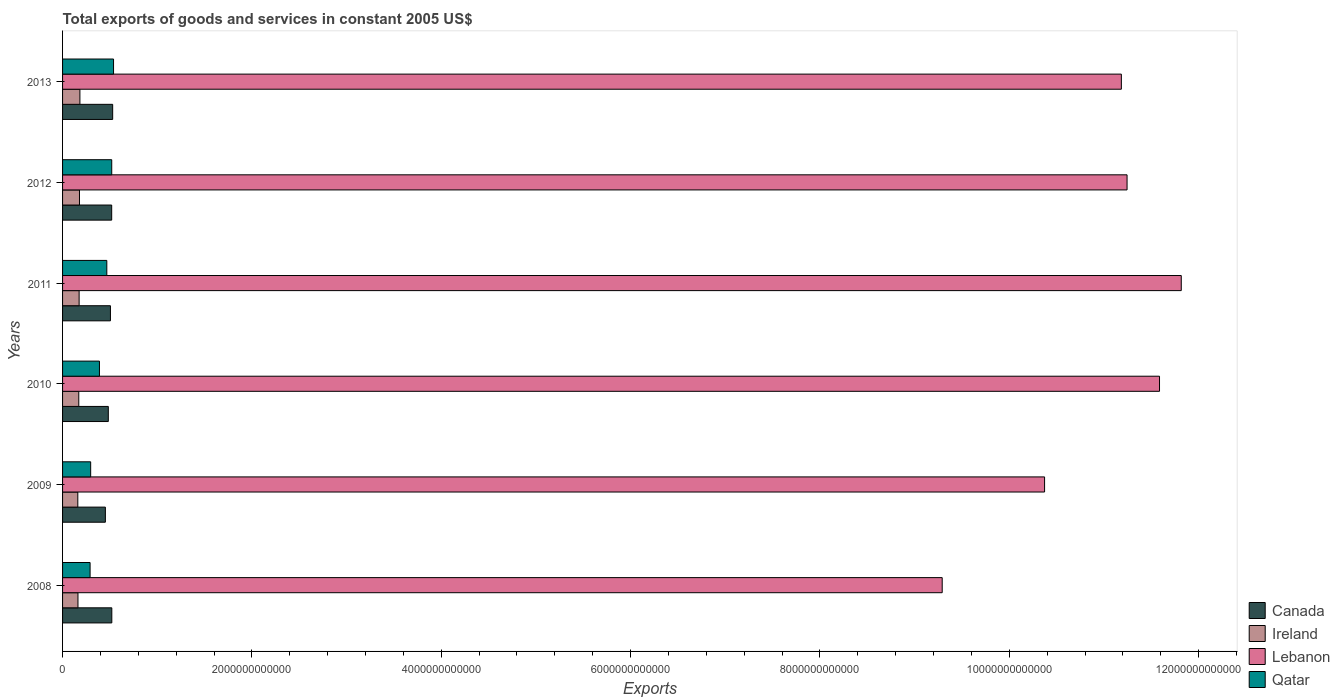How many different coloured bars are there?
Keep it short and to the point. 4. Are the number of bars per tick equal to the number of legend labels?
Offer a terse response. Yes. Are the number of bars on each tick of the Y-axis equal?
Give a very brief answer. Yes. What is the label of the 3rd group of bars from the top?
Offer a terse response. 2011. In how many cases, is the number of bars for a given year not equal to the number of legend labels?
Provide a short and direct response. 0. What is the total exports of goods and services in Canada in 2008?
Provide a short and direct response. 5.20e+11. Across all years, what is the maximum total exports of goods and services in Ireland?
Your response must be concise. 1.83e+11. Across all years, what is the minimum total exports of goods and services in Qatar?
Offer a very short reply. 2.91e+11. What is the total total exports of goods and services in Lebanon in the graph?
Provide a succinct answer. 6.55e+13. What is the difference between the total exports of goods and services in Canada in 2009 and that in 2010?
Offer a very short reply. -3.10e+1. What is the difference between the total exports of goods and services in Lebanon in 2010 and the total exports of goods and services in Qatar in 2009?
Make the answer very short. 1.13e+13. What is the average total exports of goods and services in Canada per year?
Offer a very short reply. 5.02e+11. In the year 2012, what is the difference between the total exports of goods and services in Ireland and total exports of goods and services in Lebanon?
Your answer should be compact. -1.11e+13. In how many years, is the total exports of goods and services in Ireland greater than 11200000000000 US$?
Provide a succinct answer. 0. What is the ratio of the total exports of goods and services in Lebanon in 2009 to that in 2010?
Your response must be concise. 0.9. Is the difference between the total exports of goods and services in Ireland in 2009 and 2013 greater than the difference between the total exports of goods and services in Lebanon in 2009 and 2013?
Offer a terse response. Yes. What is the difference between the highest and the second highest total exports of goods and services in Ireland?
Give a very brief answer. 4.43e+09. What is the difference between the highest and the lowest total exports of goods and services in Qatar?
Your answer should be compact. 2.48e+11. Is the sum of the total exports of goods and services in Lebanon in 2012 and 2013 greater than the maximum total exports of goods and services in Canada across all years?
Your response must be concise. Yes. What does the 2nd bar from the top in 2010 represents?
Provide a succinct answer. Lebanon. What does the 4th bar from the bottom in 2012 represents?
Provide a succinct answer. Qatar. How many bars are there?
Your answer should be compact. 24. Are all the bars in the graph horizontal?
Provide a succinct answer. Yes. What is the difference between two consecutive major ticks on the X-axis?
Give a very brief answer. 2.00e+12. Are the values on the major ticks of X-axis written in scientific E-notation?
Provide a succinct answer. No. Does the graph contain any zero values?
Provide a succinct answer. No. Does the graph contain grids?
Your answer should be very brief. No. What is the title of the graph?
Keep it short and to the point. Total exports of goods and services in constant 2005 US$. Does "Malaysia" appear as one of the legend labels in the graph?
Make the answer very short. No. What is the label or title of the X-axis?
Give a very brief answer. Exports. What is the Exports of Canada in 2008?
Your response must be concise. 5.20e+11. What is the Exports in Ireland in 2008?
Keep it short and to the point. 1.63e+11. What is the Exports in Lebanon in 2008?
Offer a terse response. 9.29e+12. What is the Exports in Qatar in 2008?
Provide a short and direct response. 2.91e+11. What is the Exports in Canada in 2009?
Your answer should be very brief. 4.52e+11. What is the Exports of Ireland in 2009?
Provide a succinct answer. 1.61e+11. What is the Exports in Lebanon in 2009?
Make the answer very short. 1.04e+13. What is the Exports in Qatar in 2009?
Your answer should be very brief. 2.97e+11. What is the Exports of Canada in 2010?
Your answer should be compact. 4.83e+11. What is the Exports of Ireland in 2010?
Provide a succinct answer. 1.71e+11. What is the Exports in Lebanon in 2010?
Offer a very short reply. 1.16e+13. What is the Exports of Qatar in 2010?
Offer a terse response. 3.90e+11. What is the Exports in Canada in 2011?
Your response must be concise. 5.06e+11. What is the Exports of Ireland in 2011?
Your answer should be very brief. 1.75e+11. What is the Exports in Lebanon in 2011?
Ensure brevity in your answer.  1.18e+13. What is the Exports of Qatar in 2011?
Give a very brief answer. 4.67e+11. What is the Exports of Canada in 2012?
Offer a very short reply. 5.19e+11. What is the Exports in Ireland in 2012?
Your answer should be compact. 1.79e+11. What is the Exports in Lebanon in 2012?
Your answer should be compact. 1.12e+13. What is the Exports of Qatar in 2012?
Offer a very short reply. 5.19e+11. What is the Exports of Canada in 2013?
Provide a short and direct response. 5.29e+11. What is the Exports of Ireland in 2013?
Your answer should be very brief. 1.83e+11. What is the Exports of Lebanon in 2013?
Offer a terse response. 1.12e+13. What is the Exports in Qatar in 2013?
Offer a terse response. 5.39e+11. Across all years, what is the maximum Exports in Canada?
Your answer should be compact. 5.29e+11. Across all years, what is the maximum Exports of Ireland?
Give a very brief answer. 1.83e+11. Across all years, what is the maximum Exports of Lebanon?
Provide a succinct answer. 1.18e+13. Across all years, what is the maximum Exports in Qatar?
Make the answer very short. 5.39e+11. Across all years, what is the minimum Exports in Canada?
Give a very brief answer. 4.52e+11. Across all years, what is the minimum Exports of Ireland?
Make the answer very short. 1.61e+11. Across all years, what is the minimum Exports in Lebanon?
Your answer should be very brief. 9.29e+12. Across all years, what is the minimum Exports in Qatar?
Keep it short and to the point. 2.91e+11. What is the total Exports in Canada in the graph?
Your response must be concise. 3.01e+12. What is the total Exports of Ireland in the graph?
Your answer should be compact. 1.03e+12. What is the total Exports of Lebanon in the graph?
Ensure brevity in your answer.  6.55e+13. What is the total Exports in Qatar in the graph?
Your answer should be very brief. 2.50e+12. What is the difference between the Exports of Canada in 2008 and that in 2009?
Give a very brief answer. 6.80e+1. What is the difference between the Exports of Ireland in 2008 and that in 2009?
Provide a succinct answer. 1.73e+09. What is the difference between the Exports of Lebanon in 2008 and that in 2009?
Your answer should be compact. -1.08e+12. What is the difference between the Exports of Qatar in 2008 and that in 2009?
Keep it short and to the point. -6.06e+09. What is the difference between the Exports of Canada in 2008 and that in 2010?
Give a very brief answer. 3.70e+1. What is the difference between the Exports of Ireland in 2008 and that in 2010?
Keep it short and to the point. -8.60e+09. What is the difference between the Exports in Lebanon in 2008 and that in 2010?
Provide a succinct answer. -2.30e+12. What is the difference between the Exports of Qatar in 2008 and that in 2010?
Provide a short and direct response. -9.89e+1. What is the difference between the Exports of Canada in 2008 and that in 2011?
Offer a terse response. 1.46e+1. What is the difference between the Exports of Ireland in 2008 and that in 2011?
Provide a short and direct response. -1.22e+1. What is the difference between the Exports of Lebanon in 2008 and that in 2011?
Ensure brevity in your answer.  -2.53e+12. What is the difference between the Exports of Qatar in 2008 and that in 2011?
Ensure brevity in your answer.  -1.77e+11. What is the difference between the Exports in Canada in 2008 and that in 2012?
Ensure brevity in your answer.  1.39e+09. What is the difference between the Exports of Ireland in 2008 and that in 2012?
Ensure brevity in your answer.  -1.60e+1. What is the difference between the Exports in Lebanon in 2008 and that in 2012?
Your response must be concise. -1.95e+12. What is the difference between the Exports of Qatar in 2008 and that in 2012?
Ensure brevity in your answer.  -2.29e+11. What is the difference between the Exports in Canada in 2008 and that in 2013?
Make the answer very short. -9.07e+09. What is the difference between the Exports of Ireland in 2008 and that in 2013?
Your answer should be compact. -2.04e+1. What is the difference between the Exports in Lebanon in 2008 and that in 2013?
Make the answer very short. -1.89e+12. What is the difference between the Exports in Qatar in 2008 and that in 2013?
Provide a short and direct response. -2.48e+11. What is the difference between the Exports in Canada in 2009 and that in 2010?
Your response must be concise. -3.10e+1. What is the difference between the Exports in Ireland in 2009 and that in 2010?
Make the answer very short. -1.03e+1. What is the difference between the Exports of Lebanon in 2009 and that in 2010?
Your answer should be very brief. -1.21e+12. What is the difference between the Exports of Qatar in 2009 and that in 2010?
Provide a succinct answer. -9.28e+1. What is the difference between the Exports of Canada in 2009 and that in 2011?
Offer a very short reply. -5.34e+1. What is the difference between the Exports of Ireland in 2009 and that in 2011?
Provide a succinct answer. -1.40e+1. What is the difference between the Exports in Lebanon in 2009 and that in 2011?
Your answer should be very brief. -1.44e+12. What is the difference between the Exports in Qatar in 2009 and that in 2011?
Provide a short and direct response. -1.70e+11. What is the difference between the Exports of Canada in 2009 and that in 2012?
Offer a terse response. -6.67e+1. What is the difference between the Exports in Ireland in 2009 and that in 2012?
Provide a succinct answer. -1.77e+1. What is the difference between the Exports in Lebanon in 2009 and that in 2012?
Keep it short and to the point. -8.71e+11. What is the difference between the Exports of Qatar in 2009 and that in 2012?
Your answer should be compact. -2.23e+11. What is the difference between the Exports in Canada in 2009 and that in 2013?
Keep it short and to the point. -7.71e+1. What is the difference between the Exports of Ireland in 2009 and that in 2013?
Ensure brevity in your answer.  -2.21e+1. What is the difference between the Exports in Lebanon in 2009 and that in 2013?
Your answer should be very brief. -8.11e+11. What is the difference between the Exports in Qatar in 2009 and that in 2013?
Your answer should be compact. -2.42e+11. What is the difference between the Exports of Canada in 2010 and that in 2011?
Make the answer very short. -2.24e+1. What is the difference between the Exports in Ireland in 2010 and that in 2011?
Provide a succinct answer. -3.65e+09. What is the difference between the Exports in Lebanon in 2010 and that in 2011?
Provide a succinct answer. -2.30e+11. What is the difference between the Exports of Qatar in 2010 and that in 2011?
Your answer should be very brief. -7.77e+1. What is the difference between the Exports of Canada in 2010 and that in 2012?
Make the answer very short. -3.56e+1. What is the difference between the Exports in Ireland in 2010 and that in 2012?
Keep it short and to the point. -7.37e+09. What is the difference between the Exports in Lebanon in 2010 and that in 2012?
Offer a very short reply. 3.43e+11. What is the difference between the Exports in Qatar in 2010 and that in 2012?
Provide a short and direct response. -1.30e+11. What is the difference between the Exports of Canada in 2010 and that in 2013?
Ensure brevity in your answer.  -4.61e+1. What is the difference between the Exports of Ireland in 2010 and that in 2013?
Ensure brevity in your answer.  -1.18e+1. What is the difference between the Exports of Lebanon in 2010 and that in 2013?
Your answer should be compact. 4.03e+11. What is the difference between the Exports in Qatar in 2010 and that in 2013?
Make the answer very short. -1.49e+11. What is the difference between the Exports in Canada in 2011 and that in 2012?
Keep it short and to the point. -1.32e+1. What is the difference between the Exports in Ireland in 2011 and that in 2012?
Your response must be concise. -3.72e+09. What is the difference between the Exports in Lebanon in 2011 and that in 2012?
Give a very brief answer. 5.72e+11. What is the difference between the Exports of Qatar in 2011 and that in 2012?
Your response must be concise. -5.20e+1. What is the difference between the Exports in Canada in 2011 and that in 2013?
Your answer should be compact. -2.37e+1. What is the difference between the Exports of Ireland in 2011 and that in 2013?
Your response must be concise. -8.15e+09. What is the difference between the Exports of Lebanon in 2011 and that in 2013?
Your response must be concise. 6.33e+11. What is the difference between the Exports in Qatar in 2011 and that in 2013?
Your response must be concise. -7.12e+1. What is the difference between the Exports of Canada in 2012 and that in 2013?
Ensure brevity in your answer.  -1.05e+1. What is the difference between the Exports of Ireland in 2012 and that in 2013?
Offer a terse response. -4.43e+09. What is the difference between the Exports in Lebanon in 2012 and that in 2013?
Keep it short and to the point. 6.03e+1. What is the difference between the Exports of Qatar in 2012 and that in 2013?
Your answer should be very brief. -1.92e+1. What is the difference between the Exports of Canada in 2008 and the Exports of Ireland in 2009?
Offer a terse response. 3.59e+11. What is the difference between the Exports in Canada in 2008 and the Exports in Lebanon in 2009?
Keep it short and to the point. -9.85e+12. What is the difference between the Exports of Canada in 2008 and the Exports of Qatar in 2009?
Give a very brief answer. 2.23e+11. What is the difference between the Exports in Ireland in 2008 and the Exports in Lebanon in 2009?
Your answer should be very brief. -1.02e+13. What is the difference between the Exports in Ireland in 2008 and the Exports in Qatar in 2009?
Offer a very short reply. -1.34e+11. What is the difference between the Exports of Lebanon in 2008 and the Exports of Qatar in 2009?
Your response must be concise. 8.99e+12. What is the difference between the Exports of Canada in 2008 and the Exports of Ireland in 2010?
Give a very brief answer. 3.49e+11. What is the difference between the Exports of Canada in 2008 and the Exports of Lebanon in 2010?
Your response must be concise. -1.11e+13. What is the difference between the Exports in Canada in 2008 and the Exports in Qatar in 2010?
Keep it short and to the point. 1.31e+11. What is the difference between the Exports of Ireland in 2008 and the Exports of Lebanon in 2010?
Keep it short and to the point. -1.14e+13. What is the difference between the Exports in Ireland in 2008 and the Exports in Qatar in 2010?
Make the answer very short. -2.27e+11. What is the difference between the Exports in Lebanon in 2008 and the Exports in Qatar in 2010?
Offer a very short reply. 8.90e+12. What is the difference between the Exports of Canada in 2008 and the Exports of Ireland in 2011?
Give a very brief answer. 3.45e+11. What is the difference between the Exports of Canada in 2008 and the Exports of Lebanon in 2011?
Give a very brief answer. -1.13e+13. What is the difference between the Exports in Canada in 2008 and the Exports in Qatar in 2011?
Provide a short and direct response. 5.29e+1. What is the difference between the Exports of Ireland in 2008 and the Exports of Lebanon in 2011?
Offer a terse response. -1.17e+13. What is the difference between the Exports of Ireland in 2008 and the Exports of Qatar in 2011?
Make the answer very short. -3.05e+11. What is the difference between the Exports in Lebanon in 2008 and the Exports in Qatar in 2011?
Ensure brevity in your answer.  8.82e+12. What is the difference between the Exports in Canada in 2008 and the Exports in Ireland in 2012?
Ensure brevity in your answer.  3.42e+11. What is the difference between the Exports of Canada in 2008 and the Exports of Lebanon in 2012?
Provide a short and direct response. -1.07e+13. What is the difference between the Exports of Canada in 2008 and the Exports of Qatar in 2012?
Give a very brief answer. 8.66e+08. What is the difference between the Exports in Ireland in 2008 and the Exports in Lebanon in 2012?
Give a very brief answer. -1.11e+13. What is the difference between the Exports of Ireland in 2008 and the Exports of Qatar in 2012?
Your answer should be compact. -3.57e+11. What is the difference between the Exports of Lebanon in 2008 and the Exports of Qatar in 2012?
Your answer should be very brief. 8.77e+12. What is the difference between the Exports in Canada in 2008 and the Exports in Ireland in 2013?
Your response must be concise. 3.37e+11. What is the difference between the Exports of Canada in 2008 and the Exports of Lebanon in 2013?
Offer a very short reply. -1.07e+13. What is the difference between the Exports in Canada in 2008 and the Exports in Qatar in 2013?
Ensure brevity in your answer.  -1.83e+1. What is the difference between the Exports in Ireland in 2008 and the Exports in Lebanon in 2013?
Give a very brief answer. -1.10e+13. What is the difference between the Exports in Ireland in 2008 and the Exports in Qatar in 2013?
Your answer should be compact. -3.76e+11. What is the difference between the Exports of Lebanon in 2008 and the Exports of Qatar in 2013?
Provide a succinct answer. 8.75e+12. What is the difference between the Exports in Canada in 2009 and the Exports in Ireland in 2010?
Offer a terse response. 2.81e+11. What is the difference between the Exports of Canada in 2009 and the Exports of Lebanon in 2010?
Your answer should be very brief. -1.11e+13. What is the difference between the Exports in Canada in 2009 and the Exports in Qatar in 2010?
Make the answer very short. 6.25e+1. What is the difference between the Exports in Ireland in 2009 and the Exports in Lebanon in 2010?
Provide a succinct answer. -1.14e+13. What is the difference between the Exports of Ireland in 2009 and the Exports of Qatar in 2010?
Your response must be concise. -2.29e+11. What is the difference between the Exports of Lebanon in 2009 and the Exports of Qatar in 2010?
Your answer should be compact. 9.98e+12. What is the difference between the Exports in Canada in 2009 and the Exports in Ireland in 2011?
Your answer should be compact. 2.77e+11. What is the difference between the Exports in Canada in 2009 and the Exports in Lebanon in 2011?
Make the answer very short. -1.14e+13. What is the difference between the Exports in Canada in 2009 and the Exports in Qatar in 2011?
Your answer should be compact. -1.51e+1. What is the difference between the Exports of Ireland in 2009 and the Exports of Lebanon in 2011?
Your answer should be compact. -1.17e+13. What is the difference between the Exports of Ireland in 2009 and the Exports of Qatar in 2011?
Keep it short and to the point. -3.06e+11. What is the difference between the Exports in Lebanon in 2009 and the Exports in Qatar in 2011?
Keep it short and to the point. 9.91e+12. What is the difference between the Exports of Canada in 2009 and the Exports of Ireland in 2012?
Your response must be concise. 2.73e+11. What is the difference between the Exports in Canada in 2009 and the Exports in Lebanon in 2012?
Provide a succinct answer. -1.08e+13. What is the difference between the Exports of Canada in 2009 and the Exports of Qatar in 2012?
Provide a short and direct response. -6.72e+1. What is the difference between the Exports of Ireland in 2009 and the Exports of Lebanon in 2012?
Your answer should be compact. -1.11e+13. What is the difference between the Exports of Ireland in 2009 and the Exports of Qatar in 2012?
Make the answer very short. -3.58e+11. What is the difference between the Exports of Lebanon in 2009 and the Exports of Qatar in 2012?
Provide a short and direct response. 9.85e+12. What is the difference between the Exports of Canada in 2009 and the Exports of Ireland in 2013?
Offer a very short reply. 2.69e+11. What is the difference between the Exports in Canada in 2009 and the Exports in Lebanon in 2013?
Your answer should be compact. -1.07e+13. What is the difference between the Exports in Canada in 2009 and the Exports in Qatar in 2013?
Your answer should be compact. -8.63e+1. What is the difference between the Exports of Ireland in 2009 and the Exports of Lebanon in 2013?
Offer a terse response. -1.10e+13. What is the difference between the Exports in Ireland in 2009 and the Exports in Qatar in 2013?
Your response must be concise. -3.78e+11. What is the difference between the Exports of Lebanon in 2009 and the Exports of Qatar in 2013?
Your response must be concise. 9.83e+12. What is the difference between the Exports in Canada in 2010 and the Exports in Ireland in 2011?
Keep it short and to the point. 3.08e+11. What is the difference between the Exports of Canada in 2010 and the Exports of Lebanon in 2011?
Offer a very short reply. -1.13e+13. What is the difference between the Exports in Canada in 2010 and the Exports in Qatar in 2011?
Make the answer very short. 1.59e+1. What is the difference between the Exports of Ireland in 2010 and the Exports of Lebanon in 2011?
Your answer should be very brief. -1.16e+13. What is the difference between the Exports in Ireland in 2010 and the Exports in Qatar in 2011?
Your answer should be compact. -2.96e+11. What is the difference between the Exports of Lebanon in 2010 and the Exports of Qatar in 2011?
Ensure brevity in your answer.  1.11e+13. What is the difference between the Exports in Canada in 2010 and the Exports in Ireland in 2012?
Your response must be concise. 3.05e+11. What is the difference between the Exports in Canada in 2010 and the Exports in Lebanon in 2012?
Keep it short and to the point. -1.08e+13. What is the difference between the Exports in Canada in 2010 and the Exports in Qatar in 2012?
Make the answer very short. -3.61e+1. What is the difference between the Exports in Ireland in 2010 and the Exports in Lebanon in 2012?
Ensure brevity in your answer.  -1.11e+13. What is the difference between the Exports in Ireland in 2010 and the Exports in Qatar in 2012?
Keep it short and to the point. -3.48e+11. What is the difference between the Exports in Lebanon in 2010 and the Exports in Qatar in 2012?
Your answer should be compact. 1.11e+13. What is the difference between the Exports of Canada in 2010 and the Exports of Ireland in 2013?
Offer a terse response. 3.00e+11. What is the difference between the Exports of Canada in 2010 and the Exports of Lebanon in 2013?
Make the answer very short. -1.07e+13. What is the difference between the Exports of Canada in 2010 and the Exports of Qatar in 2013?
Provide a succinct answer. -5.53e+1. What is the difference between the Exports in Ireland in 2010 and the Exports in Lebanon in 2013?
Offer a very short reply. -1.10e+13. What is the difference between the Exports of Ireland in 2010 and the Exports of Qatar in 2013?
Ensure brevity in your answer.  -3.67e+11. What is the difference between the Exports in Lebanon in 2010 and the Exports in Qatar in 2013?
Give a very brief answer. 1.10e+13. What is the difference between the Exports in Canada in 2011 and the Exports in Ireland in 2012?
Give a very brief answer. 3.27e+11. What is the difference between the Exports of Canada in 2011 and the Exports of Lebanon in 2012?
Your answer should be compact. -1.07e+13. What is the difference between the Exports in Canada in 2011 and the Exports in Qatar in 2012?
Make the answer very short. -1.38e+1. What is the difference between the Exports in Ireland in 2011 and the Exports in Lebanon in 2012?
Provide a succinct answer. -1.11e+13. What is the difference between the Exports in Ireland in 2011 and the Exports in Qatar in 2012?
Offer a terse response. -3.44e+11. What is the difference between the Exports in Lebanon in 2011 and the Exports in Qatar in 2012?
Give a very brief answer. 1.13e+13. What is the difference between the Exports in Canada in 2011 and the Exports in Ireland in 2013?
Keep it short and to the point. 3.22e+11. What is the difference between the Exports in Canada in 2011 and the Exports in Lebanon in 2013?
Provide a short and direct response. -1.07e+13. What is the difference between the Exports of Canada in 2011 and the Exports of Qatar in 2013?
Ensure brevity in your answer.  -3.29e+1. What is the difference between the Exports in Ireland in 2011 and the Exports in Lebanon in 2013?
Your answer should be very brief. -1.10e+13. What is the difference between the Exports in Ireland in 2011 and the Exports in Qatar in 2013?
Give a very brief answer. -3.64e+11. What is the difference between the Exports in Lebanon in 2011 and the Exports in Qatar in 2013?
Your answer should be very brief. 1.13e+13. What is the difference between the Exports in Canada in 2012 and the Exports in Ireland in 2013?
Offer a very short reply. 3.36e+11. What is the difference between the Exports of Canada in 2012 and the Exports of Lebanon in 2013?
Provide a short and direct response. -1.07e+13. What is the difference between the Exports of Canada in 2012 and the Exports of Qatar in 2013?
Keep it short and to the point. -1.97e+1. What is the difference between the Exports of Ireland in 2012 and the Exports of Lebanon in 2013?
Keep it short and to the point. -1.10e+13. What is the difference between the Exports of Ireland in 2012 and the Exports of Qatar in 2013?
Your answer should be compact. -3.60e+11. What is the difference between the Exports of Lebanon in 2012 and the Exports of Qatar in 2013?
Provide a short and direct response. 1.07e+13. What is the average Exports in Canada per year?
Ensure brevity in your answer.  5.02e+11. What is the average Exports of Ireland per year?
Ensure brevity in your answer.  1.72e+11. What is the average Exports of Lebanon per year?
Your answer should be compact. 1.09e+13. What is the average Exports of Qatar per year?
Keep it short and to the point. 4.17e+11. In the year 2008, what is the difference between the Exports in Canada and Exports in Ireland?
Your answer should be compact. 3.57e+11. In the year 2008, what is the difference between the Exports of Canada and Exports of Lebanon?
Your answer should be very brief. -8.77e+12. In the year 2008, what is the difference between the Exports of Canada and Exports of Qatar?
Give a very brief answer. 2.29e+11. In the year 2008, what is the difference between the Exports in Ireland and Exports in Lebanon?
Offer a very short reply. -9.13e+12. In the year 2008, what is the difference between the Exports in Ireland and Exports in Qatar?
Provide a succinct answer. -1.28e+11. In the year 2008, what is the difference between the Exports in Lebanon and Exports in Qatar?
Provide a succinct answer. 9.00e+12. In the year 2009, what is the difference between the Exports in Canada and Exports in Ireland?
Ensure brevity in your answer.  2.91e+11. In the year 2009, what is the difference between the Exports of Canada and Exports of Lebanon?
Keep it short and to the point. -9.92e+12. In the year 2009, what is the difference between the Exports of Canada and Exports of Qatar?
Your response must be concise. 1.55e+11. In the year 2009, what is the difference between the Exports of Ireland and Exports of Lebanon?
Make the answer very short. -1.02e+13. In the year 2009, what is the difference between the Exports of Ireland and Exports of Qatar?
Offer a terse response. -1.36e+11. In the year 2009, what is the difference between the Exports of Lebanon and Exports of Qatar?
Keep it short and to the point. 1.01e+13. In the year 2010, what is the difference between the Exports in Canada and Exports in Ireland?
Ensure brevity in your answer.  3.12e+11. In the year 2010, what is the difference between the Exports of Canada and Exports of Lebanon?
Your answer should be compact. -1.11e+13. In the year 2010, what is the difference between the Exports in Canada and Exports in Qatar?
Keep it short and to the point. 9.36e+1. In the year 2010, what is the difference between the Exports in Ireland and Exports in Lebanon?
Your response must be concise. -1.14e+13. In the year 2010, what is the difference between the Exports in Ireland and Exports in Qatar?
Your answer should be compact. -2.18e+11. In the year 2010, what is the difference between the Exports of Lebanon and Exports of Qatar?
Your answer should be compact. 1.12e+13. In the year 2011, what is the difference between the Exports of Canada and Exports of Ireland?
Keep it short and to the point. 3.31e+11. In the year 2011, what is the difference between the Exports of Canada and Exports of Lebanon?
Provide a short and direct response. -1.13e+13. In the year 2011, what is the difference between the Exports in Canada and Exports in Qatar?
Ensure brevity in your answer.  3.83e+1. In the year 2011, what is the difference between the Exports of Ireland and Exports of Lebanon?
Offer a very short reply. -1.16e+13. In the year 2011, what is the difference between the Exports in Ireland and Exports in Qatar?
Keep it short and to the point. -2.92e+11. In the year 2011, what is the difference between the Exports in Lebanon and Exports in Qatar?
Provide a succinct answer. 1.13e+13. In the year 2012, what is the difference between the Exports of Canada and Exports of Ireland?
Make the answer very short. 3.40e+11. In the year 2012, what is the difference between the Exports of Canada and Exports of Lebanon?
Make the answer very short. -1.07e+13. In the year 2012, what is the difference between the Exports in Canada and Exports in Qatar?
Your answer should be compact. -5.21e+08. In the year 2012, what is the difference between the Exports in Ireland and Exports in Lebanon?
Provide a succinct answer. -1.11e+13. In the year 2012, what is the difference between the Exports in Ireland and Exports in Qatar?
Provide a short and direct response. -3.41e+11. In the year 2012, what is the difference between the Exports in Lebanon and Exports in Qatar?
Offer a terse response. 1.07e+13. In the year 2013, what is the difference between the Exports in Canada and Exports in Ireland?
Ensure brevity in your answer.  3.46e+11. In the year 2013, what is the difference between the Exports of Canada and Exports of Lebanon?
Offer a very short reply. -1.07e+13. In the year 2013, what is the difference between the Exports of Canada and Exports of Qatar?
Your answer should be very brief. -9.23e+09. In the year 2013, what is the difference between the Exports in Ireland and Exports in Lebanon?
Offer a very short reply. -1.10e+13. In the year 2013, what is the difference between the Exports in Ireland and Exports in Qatar?
Keep it short and to the point. -3.55e+11. In the year 2013, what is the difference between the Exports of Lebanon and Exports of Qatar?
Offer a very short reply. 1.06e+13. What is the ratio of the Exports of Canada in 2008 to that in 2009?
Keep it short and to the point. 1.15. What is the ratio of the Exports in Ireland in 2008 to that in 2009?
Give a very brief answer. 1.01. What is the ratio of the Exports in Lebanon in 2008 to that in 2009?
Provide a succinct answer. 0.9. What is the ratio of the Exports of Qatar in 2008 to that in 2009?
Offer a very short reply. 0.98. What is the ratio of the Exports of Canada in 2008 to that in 2010?
Give a very brief answer. 1.08. What is the ratio of the Exports of Ireland in 2008 to that in 2010?
Ensure brevity in your answer.  0.95. What is the ratio of the Exports in Lebanon in 2008 to that in 2010?
Give a very brief answer. 0.8. What is the ratio of the Exports of Qatar in 2008 to that in 2010?
Ensure brevity in your answer.  0.75. What is the ratio of the Exports of Canada in 2008 to that in 2011?
Keep it short and to the point. 1.03. What is the ratio of the Exports of Ireland in 2008 to that in 2011?
Your response must be concise. 0.93. What is the ratio of the Exports of Lebanon in 2008 to that in 2011?
Provide a succinct answer. 0.79. What is the ratio of the Exports in Qatar in 2008 to that in 2011?
Your answer should be compact. 0.62. What is the ratio of the Exports in Ireland in 2008 to that in 2012?
Ensure brevity in your answer.  0.91. What is the ratio of the Exports in Lebanon in 2008 to that in 2012?
Make the answer very short. 0.83. What is the ratio of the Exports of Qatar in 2008 to that in 2012?
Offer a terse response. 0.56. What is the ratio of the Exports in Canada in 2008 to that in 2013?
Your answer should be very brief. 0.98. What is the ratio of the Exports of Ireland in 2008 to that in 2013?
Offer a very short reply. 0.89. What is the ratio of the Exports of Lebanon in 2008 to that in 2013?
Your response must be concise. 0.83. What is the ratio of the Exports of Qatar in 2008 to that in 2013?
Offer a very short reply. 0.54. What is the ratio of the Exports in Canada in 2009 to that in 2010?
Provide a short and direct response. 0.94. What is the ratio of the Exports of Ireland in 2009 to that in 2010?
Offer a terse response. 0.94. What is the ratio of the Exports in Lebanon in 2009 to that in 2010?
Make the answer very short. 0.9. What is the ratio of the Exports of Qatar in 2009 to that in 2010?
Offer a very short reply. 0.76. What is the ratio of the Exports in Canada in 2009 to that in 2011?
Your answer should be compact. 0.89. What is the ratio of the Exports in Ireland in 2009 to that in 2011?
Provide a short and direct response. 0.92. What is the ratio of the Exports of Lebanon in 2009 to that in 2011?
Make the answer very short. 0.88. What is the ratio of the Exports in Qatar in 2009 to that in 2011?
Keep it short and to the point. 0.64. What is the ratio of the Exports in Canada in 2009 to that in 2012?
Your answer should be very brief. 0.87. What is the ratio of the Exports in Ireland in 2009 to that in 2012?
Offer a terse response. 0.9. What is the ratio of the Exports of Lebanon in 2009 to that in 2012?
Offer a very short reply. 0.92. What is the ratio of the Exports of Qatar in 2009 to that in 2012?
Keep it short and to the point. 0.57. What is the ratio of the Exports in Canada in 2009 to that in 2013?
Keep it short and to the point. 0.85. What is the ratio of the Exports of Ireland in 2009 to that in 2013?
Your response must be concise. 0.88. What is the ratio of the Exports of Lebanon in 2009 to that in 2013?
Keep it short and to the point. 0.93. What is the ratio of the Exports of Qatar in 2009 to that in 2013?
Offer a very short reply. 0.55. What is the ratio of the Exports of Canada in 2010 to that in 2011?
Your response must be concise. 0.96. What is the ratio of the Exports of Ireland in 2010 to that in 2011?
Your answer should be compact. 0.98. What is the ratio of the Exports in Lebanon in 2010 to that in 2011?
Offer a terse response. 0.98. What is the ratio of the Exports in Qatar in 2010 to that in 2011?
Your response must be concise. 0.83. What is the ratio of the Exports of Canada in 2010 to that in 2012?
Offer a terse response. 0.93. What is the ratio of the Exports of Ireland in 2010 to that in 2012?
Provide a short and direct response. 0.96. What is the ratio of the Exports in Lebanon in 2010 to that in 2012?
Provide a short and direct response. 1.03. What is the ratio of the Exports in Qatar in 2010 to that in 2012?
Your response must be concise. 0.75. What is the ratio of the Exports of Canada in 2010 to that in 2013?
Give a very brief answer. 0.91. What is the ratio of the Exports of Ireland in 2010 to that in 2013?
Your answer should be very brief. 0.94. What is the ratio of the Exports of Lebanon in 2010 to that in 2013?
Your answer should be compact. 1.04. What is the ratio of the Exports of Qatar in 2010 to that in 2013?
Your response must be concise. 0.72. What is the ratio of the Exports in Canada in 2011 to that in 2012?
Offer a terse response. 0.97. What is the ratio of the Exports in Ireland in 2011 to that in 2012?
Ensure brevity in your answer.  0.98. What is the ratio of the Exports of Lebanon in 2011 to that in 2012?
Make the answer very short. 1.05. What is the ratio of the Exports in Qatar in 2011 to that in 2012?
Ensure brevity in your answer.  0.9. What is the ratio of the Exports of Canada in 2011 to that in 2013?
Give a very brief answer. 0.96. What is the ratio of the Exports in Ireland in 2011 to that in 2013?
Your answer should be compact. 0.96. What is the ratio of the Exports in Lebanon in 2011 to that in 2013?
Your response must be concise. 1.06. What is the ratio of the Exports in Qatar in 2011 to that in 2013?
Provide a succinct answer. 0.87. What is the ratio of the Exports in Canada in 2012 to that in 2013?
Make the answer very short. 0.98. What is the ratio of the Exports of Ireland in 2012 to that in 2013?
Provide a short and direct response. 0.98. What is the ratio of the Exports in Lebanon in 2012 to that in 2013?
Keep it short and to the point. 1.01. What is the ratio of the Exports in Qatar in 2012 to that in 2013?
Provide a short and direct response. 0.96. What is the difference between the highest and the second highest Exports in Canada?
Give a very brief answer. 9.07e+09. What is the difference between the highest and the second highest Exports in Ireland?
Offer a very short reply. 4.43e+09. What is the difference between the highest and the second highest Exports in Lebanon?
Offer a terse response. 2.30e+11. What is the difference between the highest and the second highest Exports of Qatar?
Provide a succinct answer. 1.92e+1. What is the difference between the highest and the lowest Exports of Canada?
Ensure brevity in your answer.  7.71e+1. What is the difference between the highest and the lowest Exports of Ireland?
Ensure brevity in your answer.  2.21e+1. What is the difference between the highest and the lowest Exports of Lebanon?
Your answer should be very brief. 2.53e+12. What is the difference between the highest and the lowest Exports of Qatar?
Ensure brevity in your answer.  2.48e+11. 